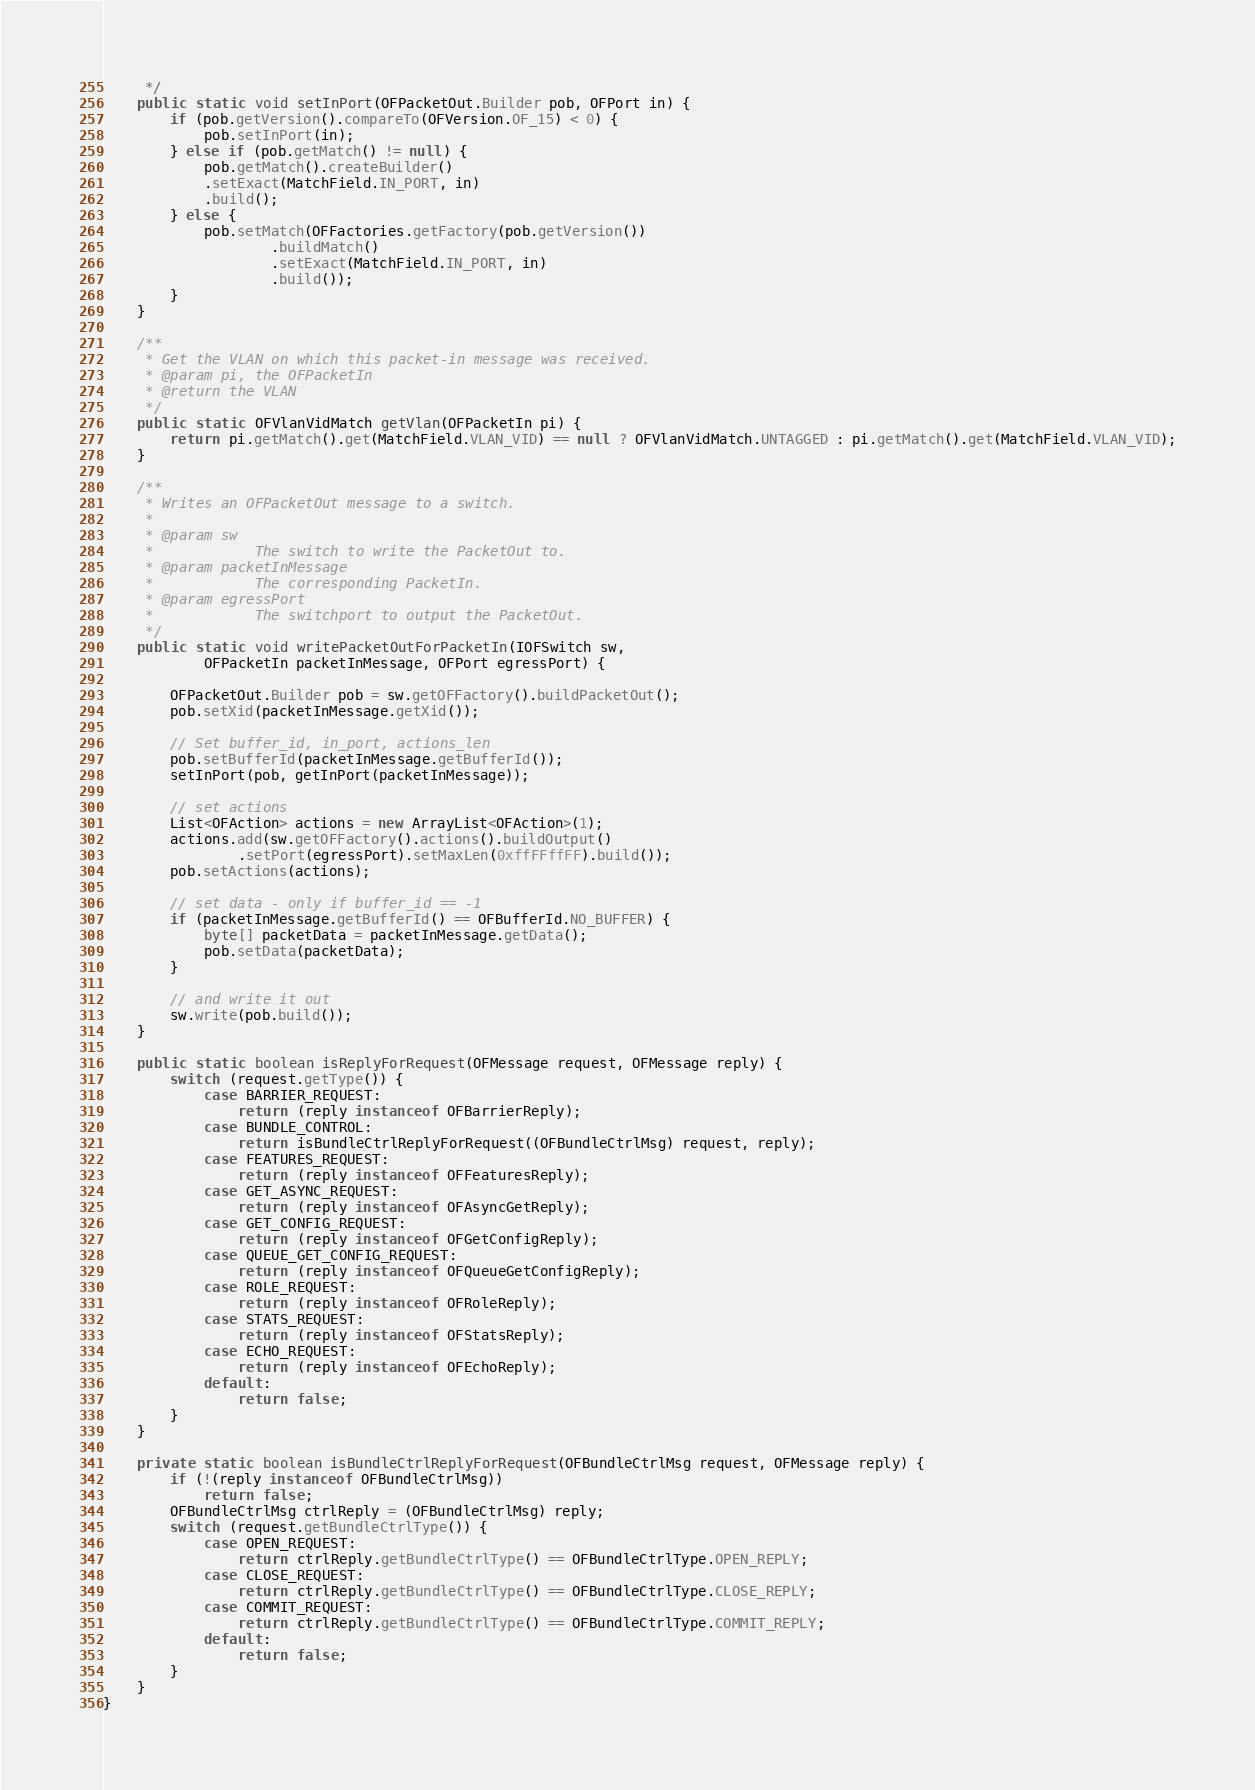Convert code to text. <code><loc_0><loc_0><loc_500><loc_500><_Java_>	 */
	public static void setInPort(OFPacketOut.Builder pob, OFPort in) {
		if (pob.getVersion().compareTo(OFVersion.OF_15) < 0) { 
			pob.setInPort(in);
		} else if (pob.getMatch() != null) {
			pob.getMatch().createBuilder()
			.setExact(MatchField.IN_PORT, in)
			.build();
		} else {
			pob.setMatch(OFFactories.getFactory(pob.getVersion())
					.buildMatch()
					.setExact(MatchField.IN_PORT, in)
					.build());
		}
	}

	/**
	 * Get the VLAN on which this packet-in message was received.
	 * @param pi, the OFPacketIn
	 * @return the VLAN
	 */
	public static OFVlanVidMatch getVlan(OFPacketIn pi) {
		return pi.getMatch().get(MatchField.VLAN_VID) == null ? OFVlanVidMatch.UNTAGGED : pi.getMatch().get(MatchField.VLAN_VID);
	}

	/**
	 * Writes an OFPacketOut message to a switch.
	 * 
	 * @param sw
	 *            The switch to write the PacketOut to.
	 * @param packetInMessage
	 *            The corresponding PacketIn.
	 * @param egressPort
	 *            The switchport to output the PacketOut.
	 */
	public static void writePacketOutForPacketIn(IOFSwitch sw,
			OFPacketIn packetInMessage, OFPort egressPort) {

		OFPacketOut.Builder pob = sw.getOFFactory().buildPacketOut();
		pob.setXid(packetInMessage.getXid());

		// Set buffer_id, in_port, actions_len
		pob.setBufferId(packetInMessage.getBufferId());
		setInPort(pob, getInPort(packetInMessage));

		// set actions
		List<OFAction> actions = new ArrayList<OFAction>(1);
		actions.add(sw.getOFFactory().actions().buildOutput()
				.setPort(egressPort).setMaxLen(0xffFFffFF).build());
		pob.setActions(actions);

		// set data - only if buffer_id == -1
		if (packetInMessage.getBufferId() == OFBufferId.NO_BUFFER) {
			byte[] packetData = packetInMessage.getData();
			pob.setData(packetData);
		}

		// and write it out
		sw.write(pob.build());
	}

	public static boolean isReplyForRequest(OFMessage request, OFMessage reply) {
		switch (request.getType()) {
			case BARRIER_REQUEST:
				return (reply instanceof OFBarrierReply);
			case BUNDLE_CONTROL:
				return isBundleCtrlReplyForRequest((OFBundleCtrlMsg) request, reply);
			case FEATURES_REQUEST:
				return (reply instanceof OFFeaturesReply);
			case GET_ASYNC_REQUEST:
				return (reply instanceof OFAsyncGetReply);
			case GET_CONFIG_REQUEST:
				return (reply instanceof OFGetConfigReply);
			case QUEUE_GET_CONFIG_REQUEST:
				return (reply instanceof OFQueueGetConfigReply);
			case ROLE_REQUEST:
				return (reply instanceof OFRoleReply);
			case STATS_REQUEST:
				return (reply instanceof OFStatsReply);
			case ECHO_REQUEST:
				return (reply instanceof OFEchoReply);
			default:
				return false;
		}
	}

	private static boolean isBundleCtrlReplyForRequest(OFBundleCtrlMsg request, OFMessage reply) {
		if (!(reply instanceof OFBundleCtrlMsg))
			return false;
		OFBundleCtrlMsg ctrlReply = (OFBundleCtrlMsg) reply;
		switch (request.getBundleCtrlType()) {
			case OPEN_REQUEST:
				return ctrlReply.getBundleCtrlType() == OFBundleCtrlType.OPEN_REPLY;
			case CLOSE_REQUEST:
				return ctrlReply.getBundleCtrlType() == OFBundleCtrlType.CLOSE_REPLY;
			case COMMIT_REQUEST:
				return ctrlReply.getBundleCtrlType() == OFBundleCtrlType.COMMIT_REPLY;
			default:
				return false;
		}
	}
}
</code> 